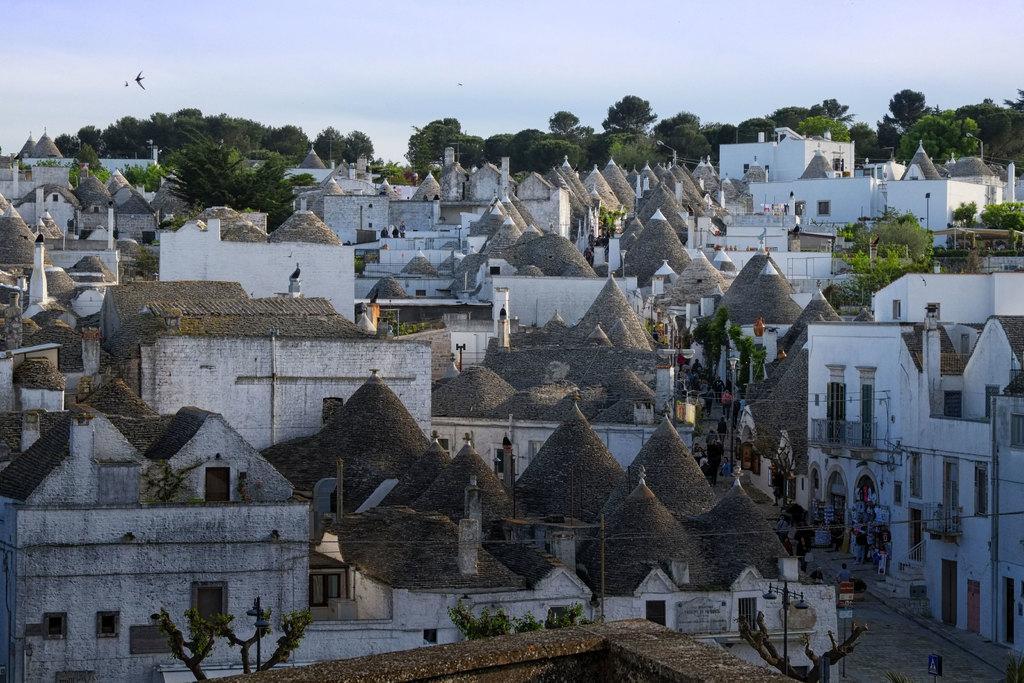Could you give a brief overview of what you see in this image? Here in this picture we can see buildings, roofs, windows, fences, trees, light poles, wires, birds flying in the air and few persons are walking on the road on the right side. In the background there are trees and clouds in the sky. 